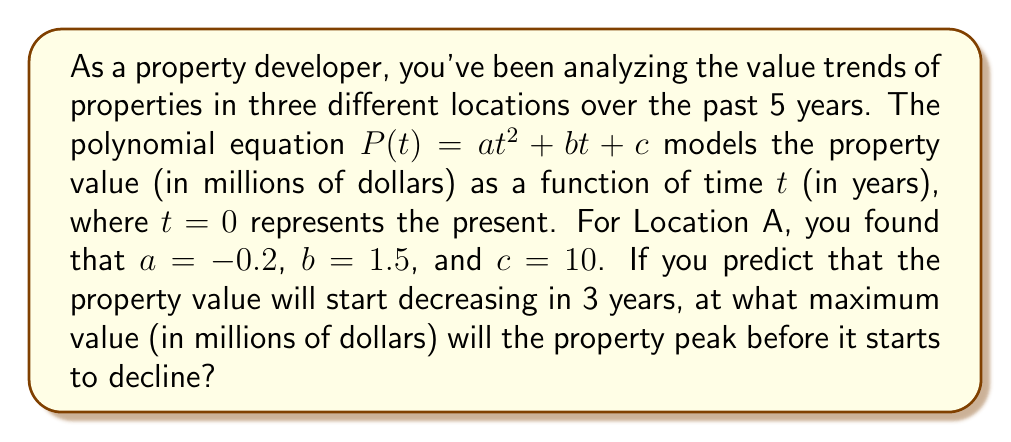Teach me how to tackle this problem. To solve this problem, we need to follow these steps:

1) The given polynomial equation is $P(t) = at^2 + bt + c$, where:
   $a = -0.2$, $b = 1.5$, and $c = 10$

2) Substituting these values, we get:
   $P(t) = -0.2t^2 + 1.5t + 10$

3) To find the maximum value, we need to find the vertex of this parabola. Since $a$ is negative, the parabola opens downward, and the vertex will be the maximum point.

4) For a quadratic equation in the form $ax^2 + bx + c$, the x-coordinate of the vertex is given by $x = -\frac{b}{2a}$

5) In our case:
   $t = -\frac{1.5}{2(-0.2)} = -\frac{1.5}{-0.4} = 3.75$

6) This means the property value will peak 3.75 years from now, which aligns with the prediction that it will start decreasing in 3 years.

7) To find the maximum value, we substitute $t = 3.75$ into our equation:

   $P(3.75) = -0.2(3.75)^2 + 1.5(3.75) + 10$
             $= -0.2(14.0625) + 5.625 + 10$
             $= -2.8125 + 5.625 + 10$
             $= 12.8125$

Therefore, the property value will peak at approximately $12.8125 million.
Answer: $12.8125$ million dollars 